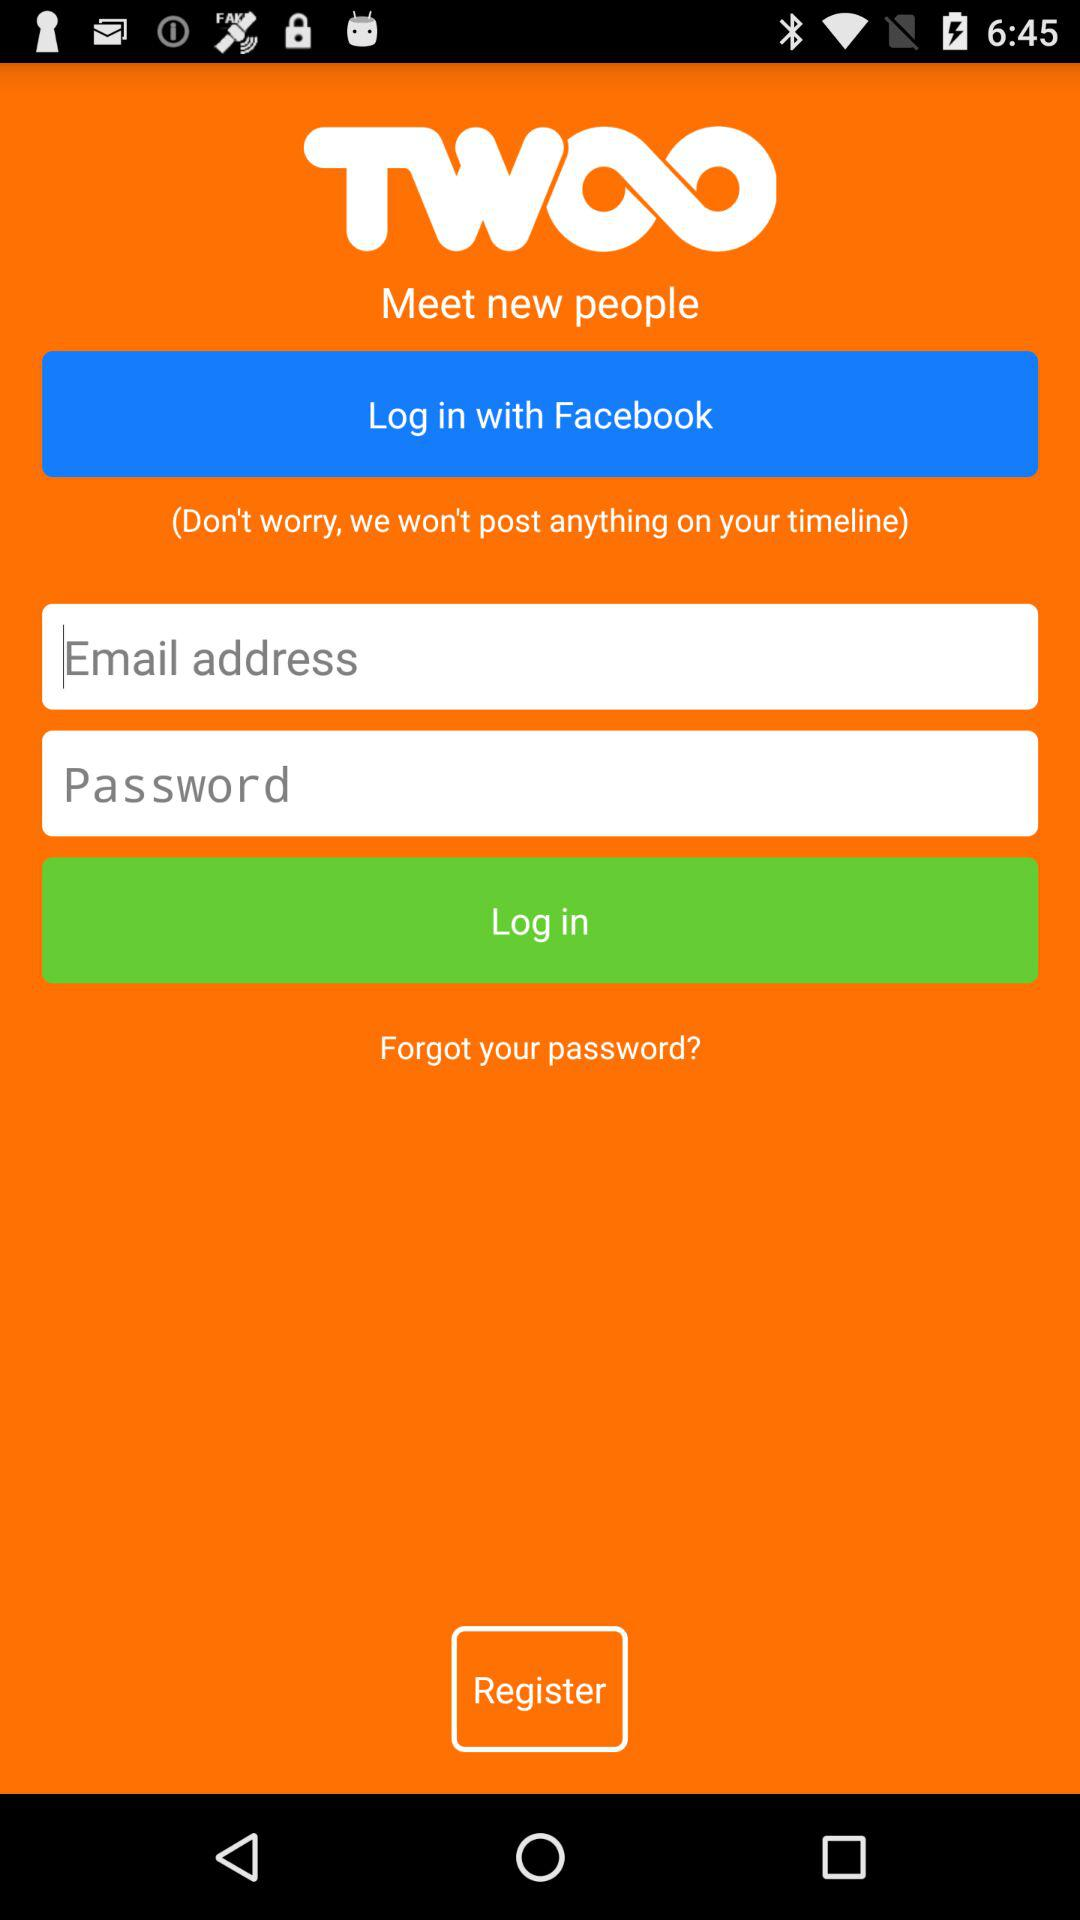What application can we use for login? You can login with "Facebook". 